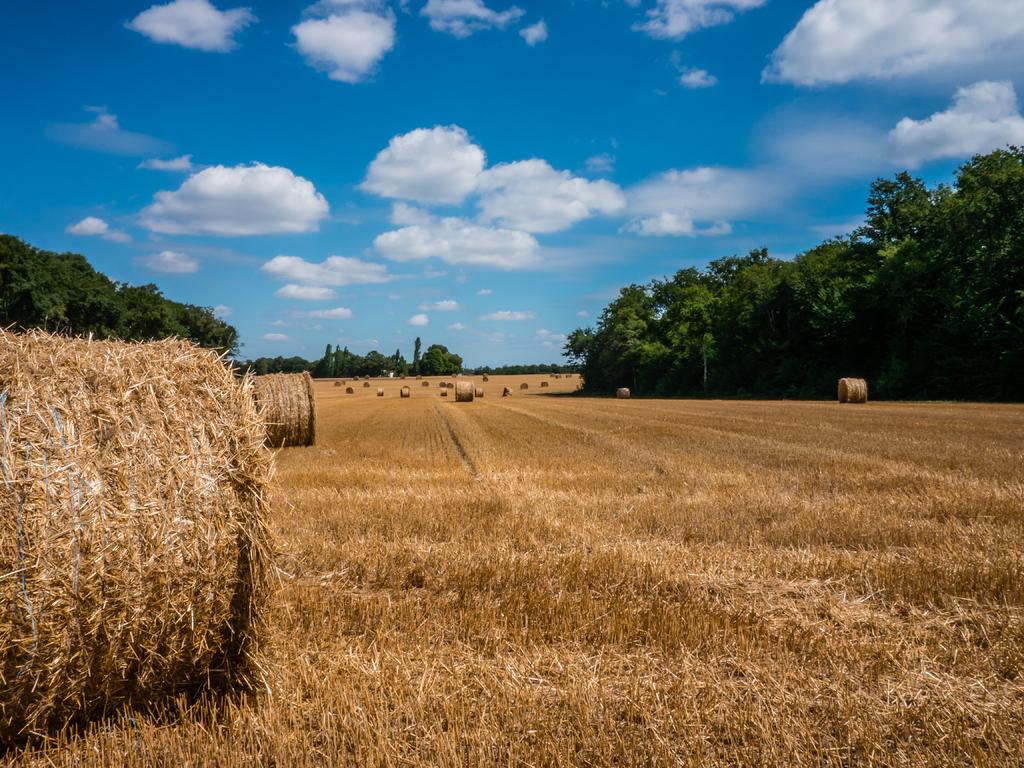What type of vegetation is present in the image? There is dried grass in the image. What can be seen in the background of the image? There are trees in the background of the image. What is the color of the trees? The trees are green in color. What is the color of the sky in the image? The sky is blue and white in color. What else can be seen in the image besides the grass and trees? There are grass rolls visible in the image. What type of quartz can be seen in the image? There is no quartz present in the image. How does the image convey a sense of hate? The image does not convey a sense of hate; it is a neutral representation of the landscape. 